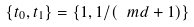<formula> <loc_0><loc_0><loc_500><loc_500>\{ t _ { 0 } , t _ { 1 } \} = \{ 1 , 1 / ( \ m d + 1 ) \}</formula> 